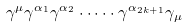<formula> <loc_0><loc_0><loc_500><loc_500>\gamma ^ { \mu } \gamma ^ { \alpha _ { 1 } } \gamma ^ { \alpha _ { 2 } } \cdot \dots \cdot \gamma ^ { \alpha _ { 2 k + 1 } } \gamma _ { \mu }</formula> 